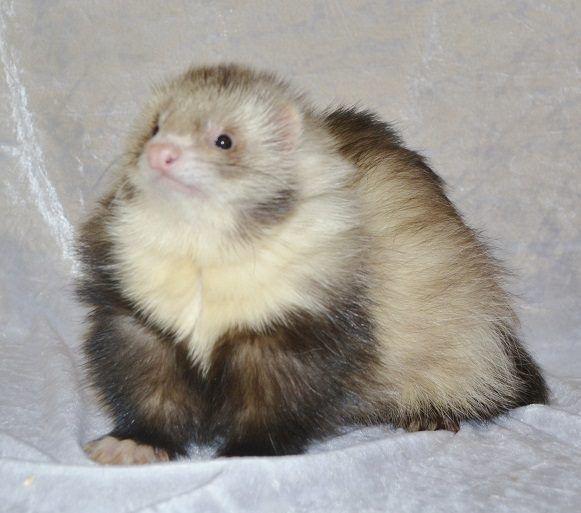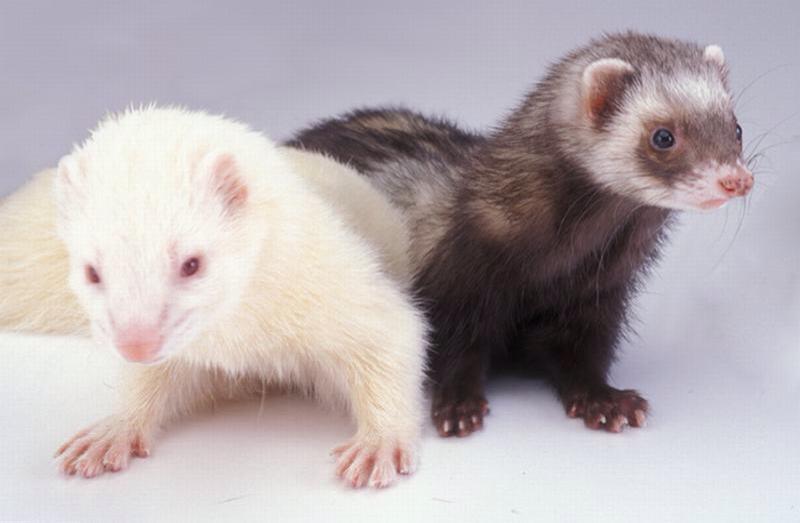The first image is the image on the left, the second image is the image on the right. Evaluate the accuracy of this statement regarding the images: "At least one image contains a cream colored and a masked ferret.". Is it true? Answer yes or no. Yes. 